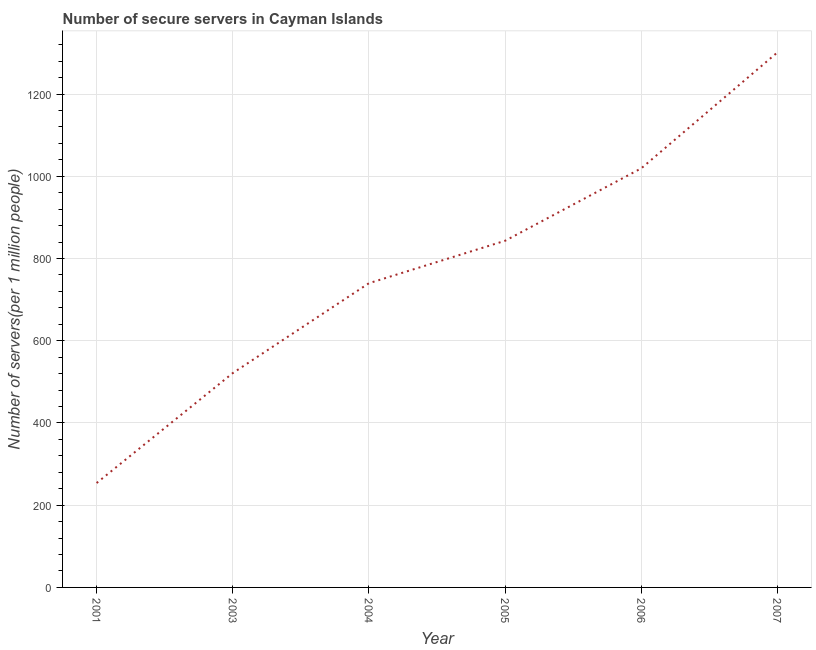What is the number of secure internet servers in 2001?
Your answer should be compact. 253.94. Across all years, what is the maximum number of secure internet servers?
Provide a short and direct response. 1301.48. Across all years, what is the minimum number of secure internet servers?
Your answer should be compact. 253.94. What is the sum of the number of secure internet servers?
Your response must be concise. 4679.42. What is the difference between the number of secure internet servers in 2003 and 2004?
Ensure brevity in your answer.  -218.6. What is the average number of secure internet servers per year?
Provide a short and direct response. 779.9. What is the median number of secure internet servers?
Your answer should be very brief. 791.6. In how many years, is the number of secure internet servers greater than 200 ?
Your answer should be very brief. 6. What is the ratio of the number of secure internet servers in 2003 to that in 2007?
Offer a terse response. 0.4. Is the difference between the number of secure internet servers in 2004 and 2005 greater than the difference between any two years?
Keep it short and to the point. No. What is the difference between the highest and the second highest number of secure internet servers?
Ensure brevity in your answer.  282.05. What is the difference between the highest and the lowest number of secure internet servers?
Your answer should be compact. 1047.53. How many lines are there?
Provide a succinct answer. 1. How many years are there in the graph?
Ensure brevity in your answer.  6. What is the difference between two consecutive major ticks on the Y-axis?
Keep it short and to the point. 200. What is the title of the graph?
Keep it short and to the point. Number of secure servers in Cayman Islands. What is the label or title of the Y-axis?
Your response must be concise. Number of servers(per 1 million people). What is the Number of servers(per 1 million people) of 2001?
Your answer should be compact. 253.94. What is the Number of servers(per 1 million people) of 2003?
Offer a terse response. 521.38. What is the Number of servers(per 1 million people) in 2004?
Offer a very short reply. 739.97. What is the Number of servers(per 1 million people) of 2005?
Give a very brief answer. 843.22. What is the Number of servers(per 1 million people) in 2006?
Keep it short and to the point. 1019.43. What is the Number of servers(per 1 million people) in 2007?
Ensure brevity in your answer.  1301.48. What is the difference between the Number of servers(per 1 million people) in 2001 and 2003?
Your answer should be very brief. -267.43. What is the difference between the Number of servers(per 1 million people) in 2001 and 2004?
Offer a terse response. -486.03. What is the difference between the Number of servers(per 1 million people) in 2001 and 2005?
Provide a short and direct response. -589.28. What is the difference between the Number of servers(per 1 million people) in 2001 and 2006?
Keep it short and to the point. -765.49. What is the difference between the Number of servers(per 1 million people) in 2001 and 2007?
Offer a terse response. -1047.53. What is the difference between the Number of servers(per 1 million people) in 2003 and 2004?
Your answer should be very brief. -218.6. What is the difference between the Number of servers(per 1 million people) in 2003 and 2005?
Your response must be concise. -321.85. What is the difference between the Number of servers(per 1 million people) in 2003 and 2006?
Keep it short and to the point. -498.05. What is the difference between the Number of servers(per 1 million people) in 2003 and 2007?
Your answer should be compact. -780.1. What is the difference between the Number of servers(per 1 million people) in 2004 and 2005?
Offer a very short reply. -103.25. What is the difference between the Number of servers(per 1 million people) in 2004 and 2006?
Keep it short and to the point. -279.46. What is the difference between the Number of servers(per 1 million people) in 2004 and 2007?
Make the answer very short. -561.5. What is the difference between the Number of servers(per 1 million people) in 2005 and 2006?
Offer a very short reply. -176.21. What is the difference between the Number of servers(per 1 million people) in 2005 and 2007?
Keep it short and to the point. -458.25. What is the difference between the Number of servers(per 1 million people) in 2006 and 2007?
Keep it short and to the point. -282.05. What is the ratio of the Number of servers(per 1 million people) in 2001 to that in 2003?
Your answer should be compact. 0.49. What is the ratio of the Number of servers(per 1 million people) in 2001 to that in 2004?
Provide a short and direct response. 0.34. What is the ratio of the Number of servers(per 1 million people) in 2001 to that in 2005?
Your answer should be very brief. 0.3. What is the ratio of the Number of servers(per 1 million people) in 2001 to that in 2006?
Your answer should be compact. 0.25. What is the ratio of the Number of servers(per 1 million people) in 2001 to that in 2007?
Your response must be concise. 0.2. What is the ratio of the Number of servers(per 1 million people) in 2003 to that in 2004?
Your answer should be compact. 0.7. What is the ratio of the Number of servers(per 1 million people) in 2003 to that in 2005?
Your answer should be very brief. 0.62. What is the ratio of the Number of servers(per 1 million people) in 2003 to that in 2006?
Ensure brevity in your answer.  0.51. What is the ratio of the Number of servers(per 1 million people) in 2003 to that in 2007?
Make the answer very short. 0.4. What is the ratio of the Number of servers(per 1 million people) in 2004 to that in 2005?
Keep it short and to the point. 0.88. What is the ratio of the Number of servers(per 1 million people) in 2004 to that in 2006?
Give a very brief answer. 0.73. What is the ratio of the Number of servers(per 1 million people) in 2004 to that in 2007?
Make the answer very short. 0.57. What is the ratio of the Number of servers(per 1 million people) in 2005 to that in 2006?
Your response must be concise. 0.83. What is the ratio of the Number of servers(per 1 million people) in 2005 to that in 2007?
Provide a succinct answer. 0.65. What is the ratio of the Number of servers(per 1 million people) in 2006 to that in 2007?
Give a very brief answer. 0.78. 